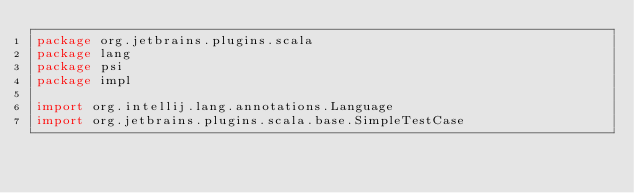<code> <loc_0><loc_0><loc_500><loc_500><_Scala_>package org.jetbrains.plugins.scala
package lang
package psi
package impl

import org.intellij.lang.annotations.Language
import org.jetbrains.plugins.scala.base.SimpleTestCase</code> 